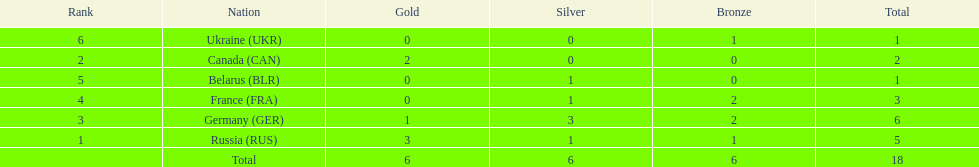Parse the full table. {'header': ['Rank', 'Nation', 'Gold', 'Silver', 'Bronze', 'Total'], 'rows': [['6', 'Ukraine\xa0(UKR)', '0', '0', '1', '1'], ['2', 'Canada\xa0(CAN)', '2', '0', '0', '2'], ['5', 'Belarus\xa0(BLR)', '0', '1', '0', '1'], ['4', 'France\xa0(FRA)', '0', '1', '2', '3'], ['3', 'Germany\xa0(GER)', '1', '3', '2', '6'], ['1', 'Russia\xa0(RUS)', '3', '1', '1', '5'], ['', 'Total', '6', '6', '6', '18']]} What country only received gold medals in the 1994 winter olympics biathlon? Canada (CAN). 